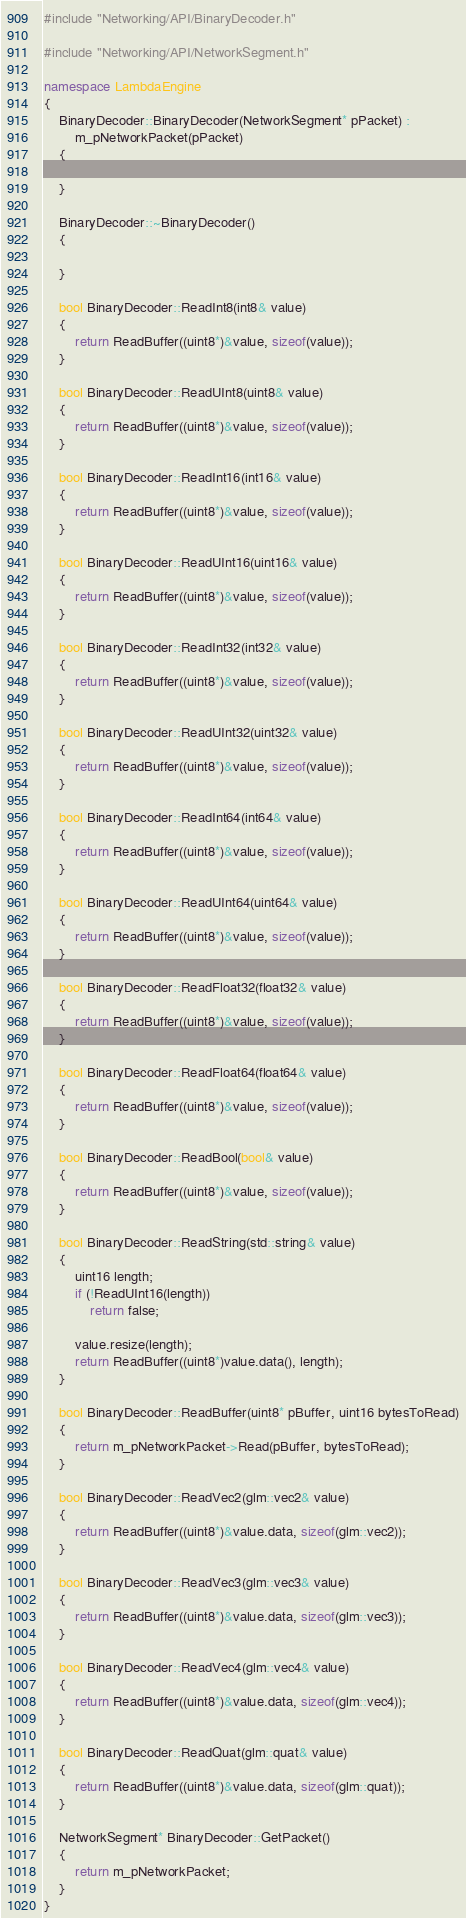<code> <loc_0><loc_0><loc_500><loc_500><_C++_>#include "Networking/API/BinaryDecoder.h"

#include "Networking/API/NetworkSegment.h"

namespace LambdaEngine
{
	BinaryDecoder::BinaryDecoder(NetworkSegment* pPacket) :
		m_pNetworkPacket(pPacket)
	{

	}

	BinaryDecoder::~BinaryDecoder()
	{

	}

	bool BinaryDecoder::ReadInt8(int8& value)
	{
		return ReadBuffer((uint8*)&value, sizeof(value));
	}

	bool BinaryDecoder::ReadUInt8(uint8& value)
	{
		return ReadBuffer((uint8*)&value, sizeof(value));
	}

	bool BinaryDecoder::ReadInt16(int16& value)
	{
		return ReadBuffer((uint8*)&value, sizeof(value));
	}

	bool BinaryDecoder::ReadUInt16(uint16& value)
	{
		return ReadBuffer((uint8*)&value, sizeof(value));
	}

	bool BinaryDecoder::ReadInt32(int32& value)
	{
		return ReadBuffer((uint8*)&value, sizeof(value));
	}

	bool BinaryDecoder::ReadUInt32(uint32& value)
	{
		return ReadBuffer((uint8*)&value, sizeof(value));
	}

	bool BinaryDecoder::ReadInt64(int64& value)
	{
		return ReadBuffer((uint8*)&value, sizeof(value));
	}

	bool BinaryDecoder::ReadUInt64(uint64& value)
	{
		return ReadBuffer((uint8*)&value, sizeof(value));
	}

	bool BinaryDecoder::ReadFloat32(float32& value)
	{
		return ReadBuffer((uint8*)&value, sizeof(value));
	}

	bool BinaryDecoder::ReadFloat64(float64& value)
	{
		return ReadBuffer((uint8*)&value, sizeof(value));
	}

	bool BinaryDecoder::ReadBool(bool& value)
	{
		return ReadBuffer((uint8*)&value, sizeof(value));
	}

	bool BinaryDecoder::ReadString(std::string& value)
	{
		uint16 length;
		if (!ReadUInt16(length))
			return false;

		value.resize(length);
		return ReadBuffer((uint8*)value.data(), length);
	}

	bool BinaryDecoder::ReadBuffer(uint8* pBuffer, uint16 bytesToRead)
	{
		return m_pNetworkPacket->Read(pBuffer, bytesToRead);
	}

	bool BinaryDecoder::ReadVec2(glm::vec2& value)
	{
		return ReadBuffer((uint8*)&value.data, sizeof(glm::vec2));
	}

	bool BinaryDecoder::ReadVec3(glm::vec3& value)
	{
		return ReadBuffer((uint8*)&value.data, sizeof(glm::vec3));
	}

	bool BinaryDecoder::ReadVec4(glm::vec4& value)
	{
		return ReadBuffer((uint8*)&value.data, sizeof(glm::vec4));
	}

	bool BinaryDecoder::ReadQuat(glm::quat& value)
	{
		return ReadBuffer((uint8*)&value.data, sizeof(glm::quat));
	}

	NetworkSegment* BinaryDecoder::GetPacket()
	{
		return m_pNetworkPacket;
	}
}</code> 